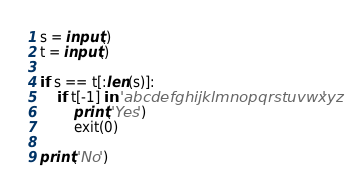Convert code to text. <code><loc_0><loc_0><loc_500><loc_500><_Python_>s = input()
t = input()
     
if s == t[:len(s)]:
	if t[-1] in 'abcdefghijklmnopqrstuvwxyz'
		print('Yes')
        exit(0)
        
print('No')</code> 